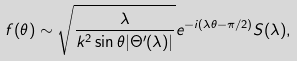Convert formula to latex. <formula><loc_0><loc_0><loc_500><loc_500>f ( \theta ) \sim \sqrt { \frac { \lambda } { k ^ { 2 } \sin \theta | \Theta ^ { \prime } ( \lambda ) | } } e ^ { - i ( \lambda \theta - \pi / 2 ) } S ( \lambda ) ,</formula> 